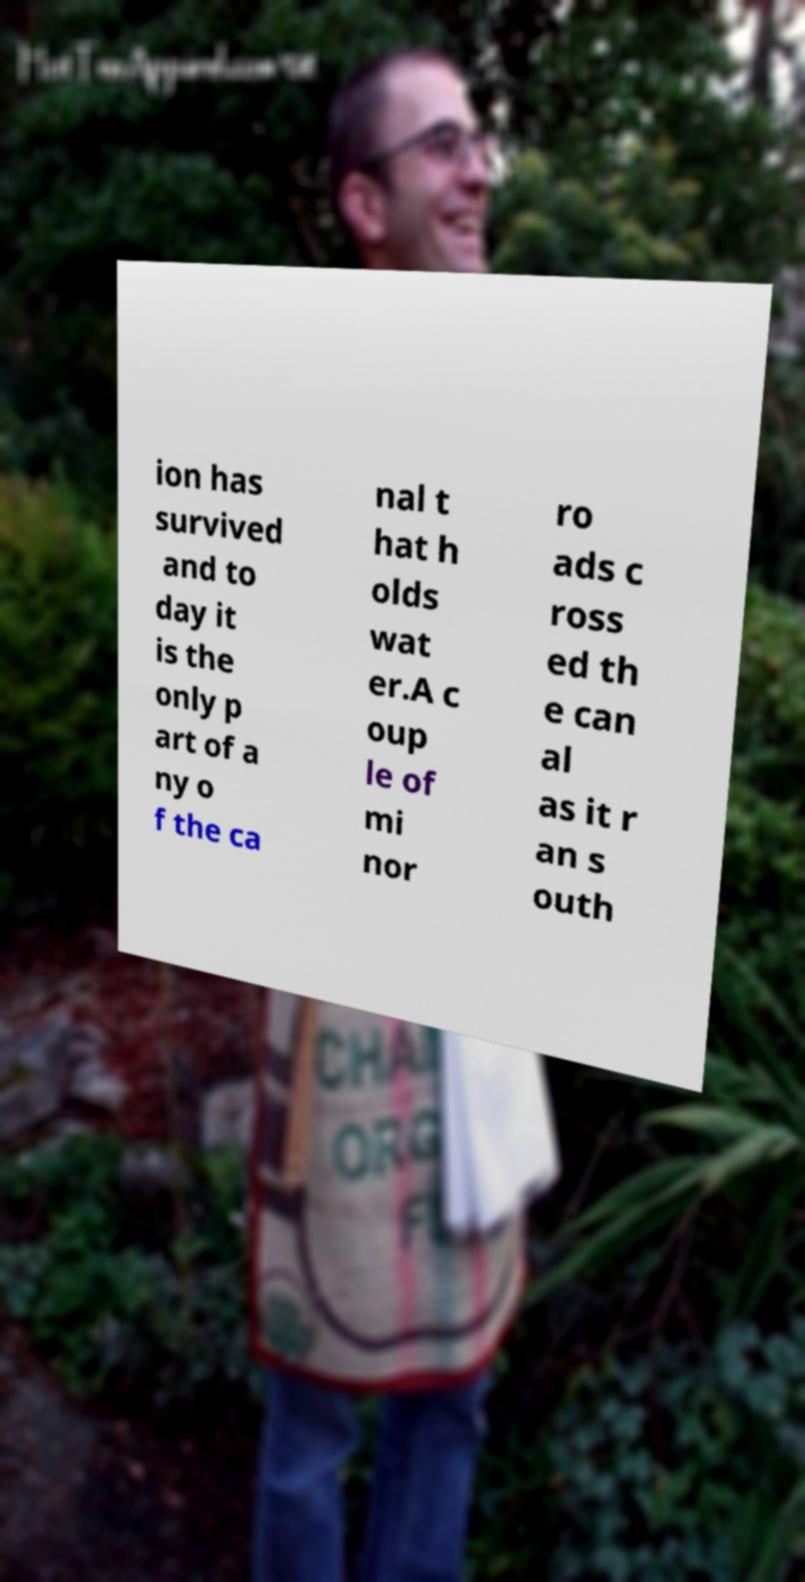Please read and relay the text visible in this image. What does it say? ion has survived and to day it is the only p art of a ny o f the ca nal t hat h olds wat er.A c oup le of mi nor ro ads c ross ed th e can al as it r an s outh 